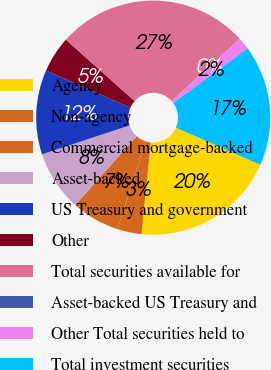Convert chart to OTSL. <chart><loc_0><loc_0><loc_500><loc_500><pie_chart><fcel>Agency<fcel>Non-agency<fcel>Commercial mortgage-backed<fcel>Asset-backed<fcel>US Treasury and government<fcel>Other<fcel>Total securities available for<fcel>Asset-backed US Treasury and<fcel>Other Total securities held to<fcel>Total investment securities<nl><fcel>19.99%<fcel>3.34%<fcel>6.67%<fcel>8.33%<fcel>11.67%<fcel>5.0%<fcel>26.65%<fcel>0.01%<fcel>1.67%<fcel>16.66%<nl></chart> 